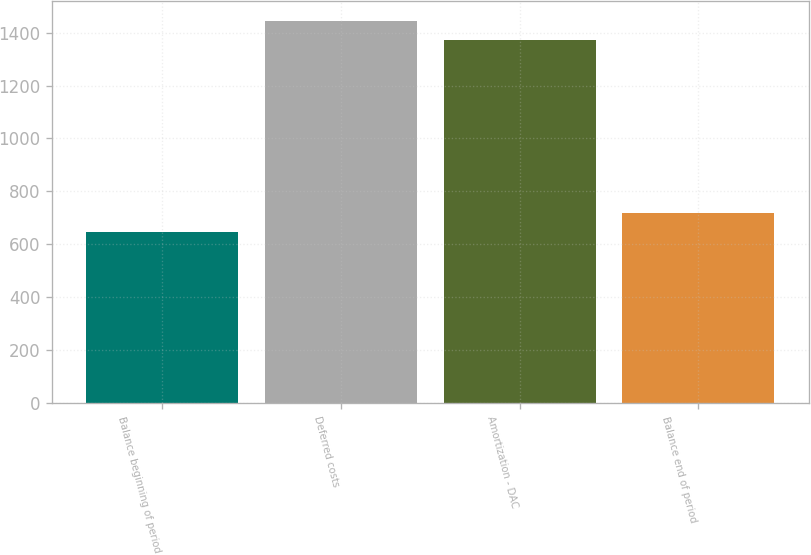<chart> <loc_0><loc_0><loc_500><loc_500><bar_chart><fcel>Balance beginning of period<fcel>Deferred costs<fcel>Amortization - DAC<fcel>Balance end of period<nl><fcel>645<fcel>1445.2<fcel>1372<fcel>718.2<nl></chart> 